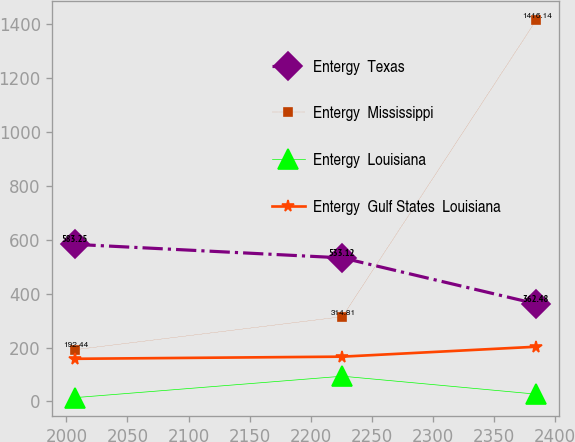Convert chart. <chart><loc_0><loc_0><loc_500><loc_500><line_chart><ecel><fcel>Entergy  Texas<fcel>Entergy  Mississippi<fcel>Entergy  Louisiana<fcel>Entergy  Gulf States  Louisiana<nl><fcel>2007.47<fcel>583.25<fcel>192.44<fcel>14.32<fcel>158.42<nl><fcel>2225.93<fcel>533.12<fcel>314.81<fcel>93.76<fcel>166.37<nl><fcel>2384.52<fcel>362.48<fcel>1416.14<fcel>27.07<fcel>203.2<nl></chart> 